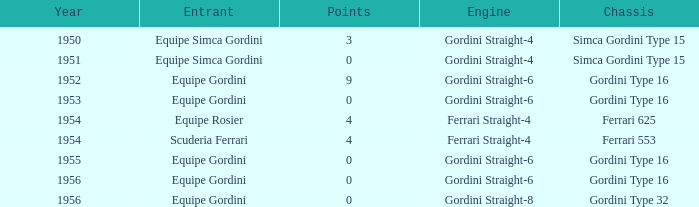What engine was used by Equipe Simca Gordini before 1956 with less than 4 points? Gordini Straight-4, Gordini Straight-4. 